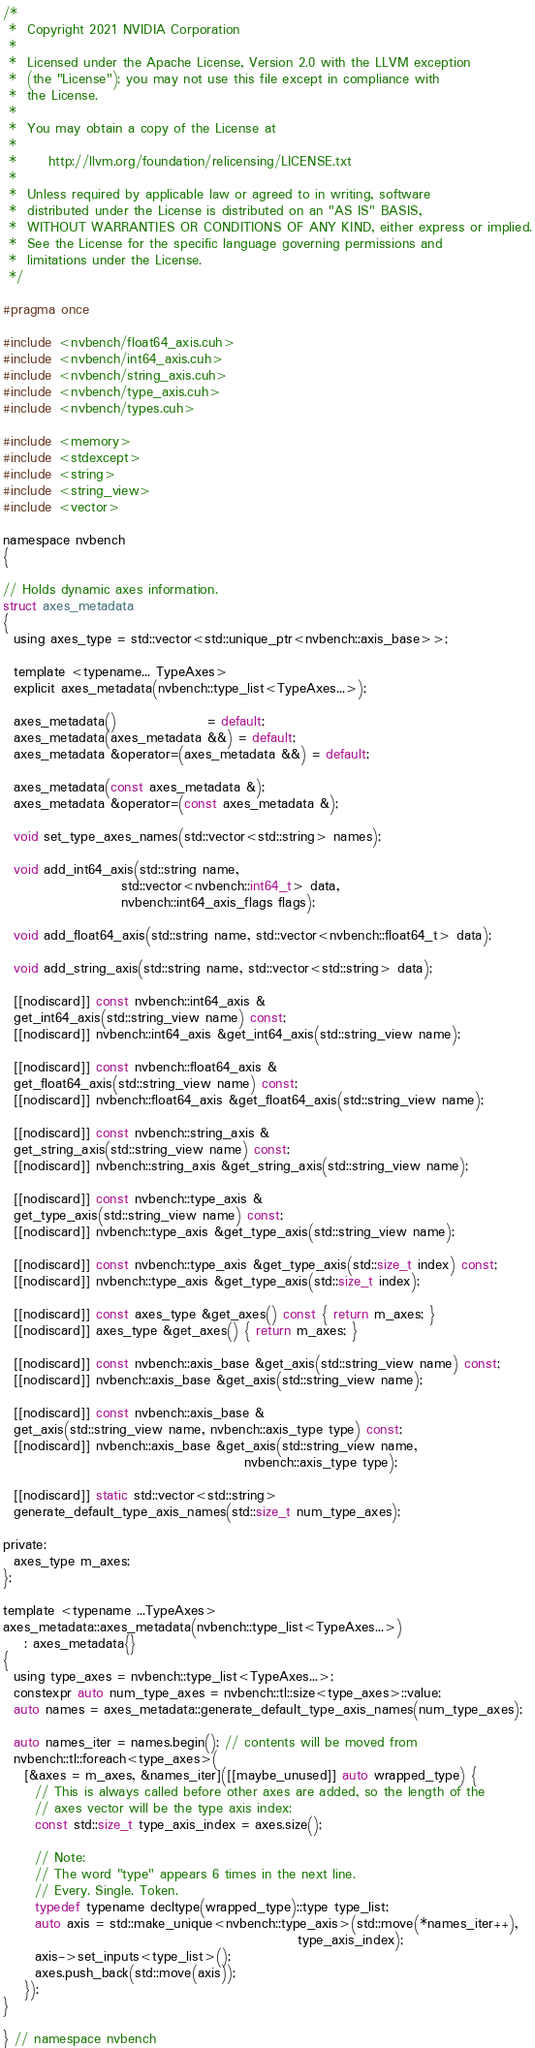<code> <loc_0><loc_0><loc_500><loc_500><_Cuda_>/*
 *  Copyright 2021 NVIDIA Corporation
 *
 *  Licensed under the Apache License, Version 2.0 with the LLVM exception
 *  (the "License"); you may not use this file except in compliance with
 *  the License.
 *
 *  You may obtain a copy of the License at
 *
 *      http://llvm.org/foundation/relicensing/LICENSE.txt
 *
 *  Unless required by applicable law or agreed to in writing, software
 *  distributed under the License is distributed on an "AS IS" BASIS,
 *  WITHOUT WARRANTIES OR CONDITIONS OF ANY KIND, either express or implied.
 *  See the License for the specific language governing permissions and
 *  limitations under the License.
 */

#pragma once

#include <nvbench/float64_axis.cuh>
#include <nvbench/int64_axis.cuh>
#include <nvbench/string_axis.cuh>
#include <nvbench/type_axis.cuh>
#include <nvbench/types.cuh>

#include <memory>
#include <stdexcept>
#include <string>
#include <string_view>
#include <vector>

namespace nvbench
{

// Holds dynamic axes information.
struct axes_metadata
{
  using axes_type = std::vector<std::unique_ptr<nvbench::axis_base>>;

  template <typename... TypeAxes>
  explicit axes_metadata(nvbench::type_list<TypeAxes...>);

  axes_metadata()                 = default;
  axes_metadata(axes_metadata &&) = default;
  axes_metadata &operator=(axes_metadata &&) = default;

  axes_metadata(const axes_metadata &);
  axes_metadata &operator=(const axes_metadata &);

  void set_type_axes_names(std::vector<std::string> names);

  void add_int64_axis(std::string name,
                      std::vector<nvbench::int64_t> data,
                      nvbench::int64_axis_flags flags);

  void add_float64_axis(std::string name, std::vector<nvbench::float64_t> data);

  void add_string_axis(std::string name, std::vector<std::string> data);

  [[nodiscard]] const nvbench::int64_axis &
  get_int64_axis(std::string_view name) const;
  [[nodiscard]] nvbench::int64_axis &get_int64_axis(std::string_view name);

  [[nodiscard]] const nvbench::float64_axis &
  get_float64_axis(std::string_view name) const;
  [[nodiscard]] nvbench::float64_axis &get_float64_axis(std::string_view name);

  [[nodiscard]] const nvbench::string_axis &
  get_string_axis(std::string_view name) const;
  [[nodiscard]] nvbench::string_axis &get_string_axis(std::string_view name);

  [[nodiscard]] const nvbench::type_axis &
  get_type_axis(std::string_view name) const;
  [[nodiscard]] nvbench::type_axis &get_type_axis(std::string_view name);

  [[nodiscard]] const nvbench::type_axis &get_type_axis(std::size_t index) const;
  [[nodiscard]] nvbench::type_axis &get_type_axis(std::size_t index);

  [[nodiscard]] const axes_type &get_axes() const { return m_axes; }
  [[nodiscard]] axes_type &get_axes() { return m_axes; }

  [[nodiscard]] const nvbench::axis_base &get_axis(std::string_view name) const;
  [[nodiscard]] nvbench::axis_base &get_axis(std::string_view name);

  [[nodiscard]] const nvbench::axis_base &
  get_axis(std::string_view name, nvbench::axis_type type) const;
  [[nodiscard]] nvbench::axis_base &get_axis(std::string_view name,
                                             nvbench::axis_type type);

  [[nodiscard]] static std::vector<std::string>
  generate_default_type_axis_names(std::size_t num_type_axes);

private:
  axes_type m_axes;
};

template <typename ...TypeAxes>
axes_metadata::axes_metadata(nvbench::type_list<TypeAxes...>)
    : axes_metadata{}
{
  using type_axes = nvbench::type_list<TypeAxes...>;
  constexpr auto num_type_axes = nvbench::tl::size<type_axes>::value;
  auto names = axes_metadata::generate_default_type_axis_names(num_type_axes);

  auto names_iter = names.begin(); // contents will be moved from
  nvbench::tl::foreach<type_axes>(
    [&axes = m_axes, &names_iter]([[maybe_unused]] auto wrapped_type) {
      // This is always called before other axes are added, so the length of the
      // axes vector will be the type axis index:
      const std::size_t type_axis_index = axes.size();

      // Note:
      // The word "type" appears 6 times in the next line.
      // Every. Single. Token.
      typedef typename decltype(wrapped_type)::type type_list;
      auto axis = std::make_unique<nvbench::type_axis>(std::move(*names_iter++),
                                                       type_axis_index);
      axis->set_inputs<type_list>();
      axes.push_back(std::move(axis));
    });
}

} // namespace nvbench
</code> 